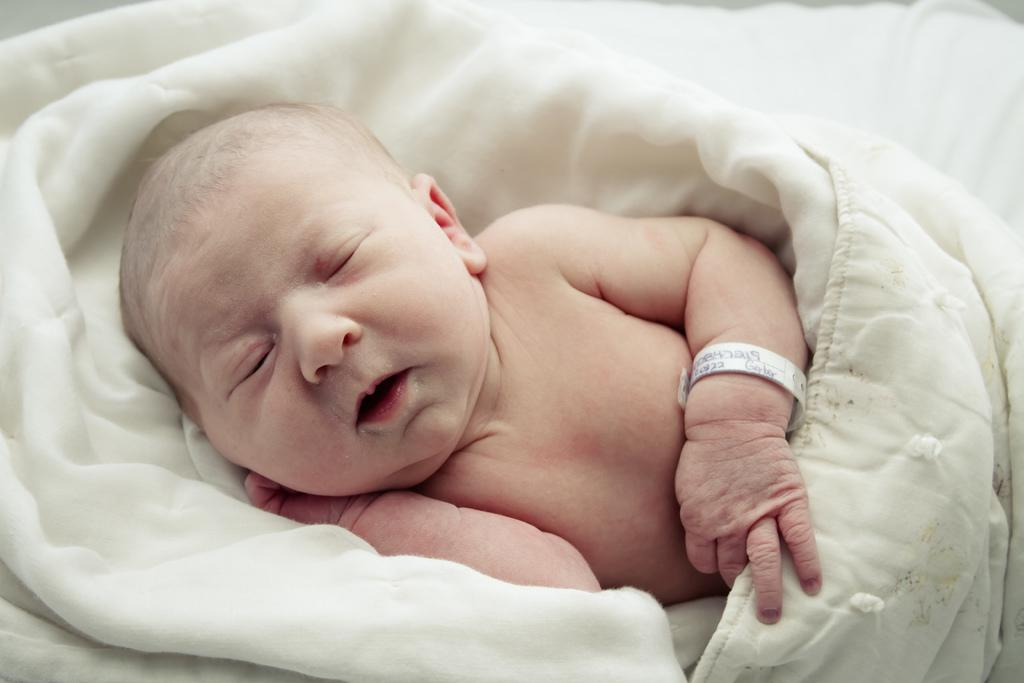What is the main subject of the image? There is a baby in the image. What is the baby doing in the image? The baby is sleeping. What is covering the baby in the image? The baby is covered by a white blanket. How many managers are present in the image? There are no managers present in the image; it features a baby sleeping under a white blanket. What type of tent is visible in the image? There is no tent present in the image. 